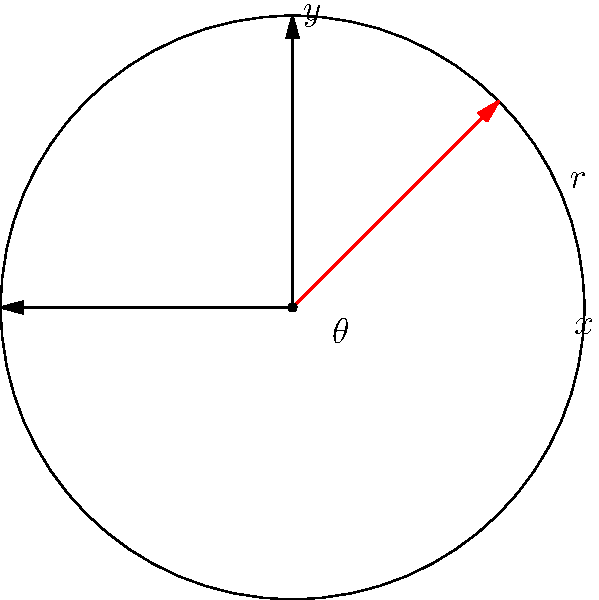In a circular video playback control interface, the position of the playback indicator is represented using polar coordinates $(r, \theta)$. The radius $r$ is fixed at 3 units, and $\theta$ varies from 0 to $2\pi$ radians as the video progresses. If the current position of the indicator is at $\theta = \frac{\pi}{4}$ radians, what are the Cartesian coordinates $(x, y)$ of the indicator? To solve this problem, we need to convert from polar coordinates to Cartesian coordinates. The conversion formulas are:

1) $x = r \cos(\theta)$
2) $y = r \sin(\theta)$

Given:
- $r = 3$ units
- $\theta = \frac{\pi}{4}$ radians

Step 1: Calculate x-coordinate
$x = r \cos(\theta) = 3 \cos(\frac{\pi}{4})$

$\cos(\frac{\pi}{4}) = \frac{\sqrt{2}}{2}$

So, $x = 3 \cdot \frac{\sqrt{2}}{2} = \frac{3\sqrt{2}}{2}$

Step 2: Calculate y-coordinate
$y = r \sin(\theta) = 3 \sin(\frac{\pi}{4})$

$\sin(\frac{\pi}{4}) = \frac{\sqrt{2}}{2}$

So, $y = 3 \cdot \frac{\sqrt{2}}{2} = \frac{3\sqrt{2}}{2}$

Therefore, the Cartesian coordinates of the indicator are $(\frac{3\sqrt{2}}{2}, \frac{3\sqrt{2}}{2})$.
Answer: $(\frac{3\sqrt{2}}{2}, \frac{3\sqrt{2}}{2})$ 